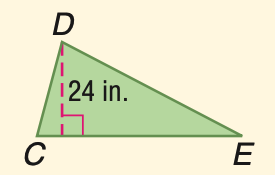Question: Triangle C D E has an area of 336 square inches. Find C E.
Choices:
A. 24
B. 26
C. 28
D. 32
Answer with the letter. Answer: C 